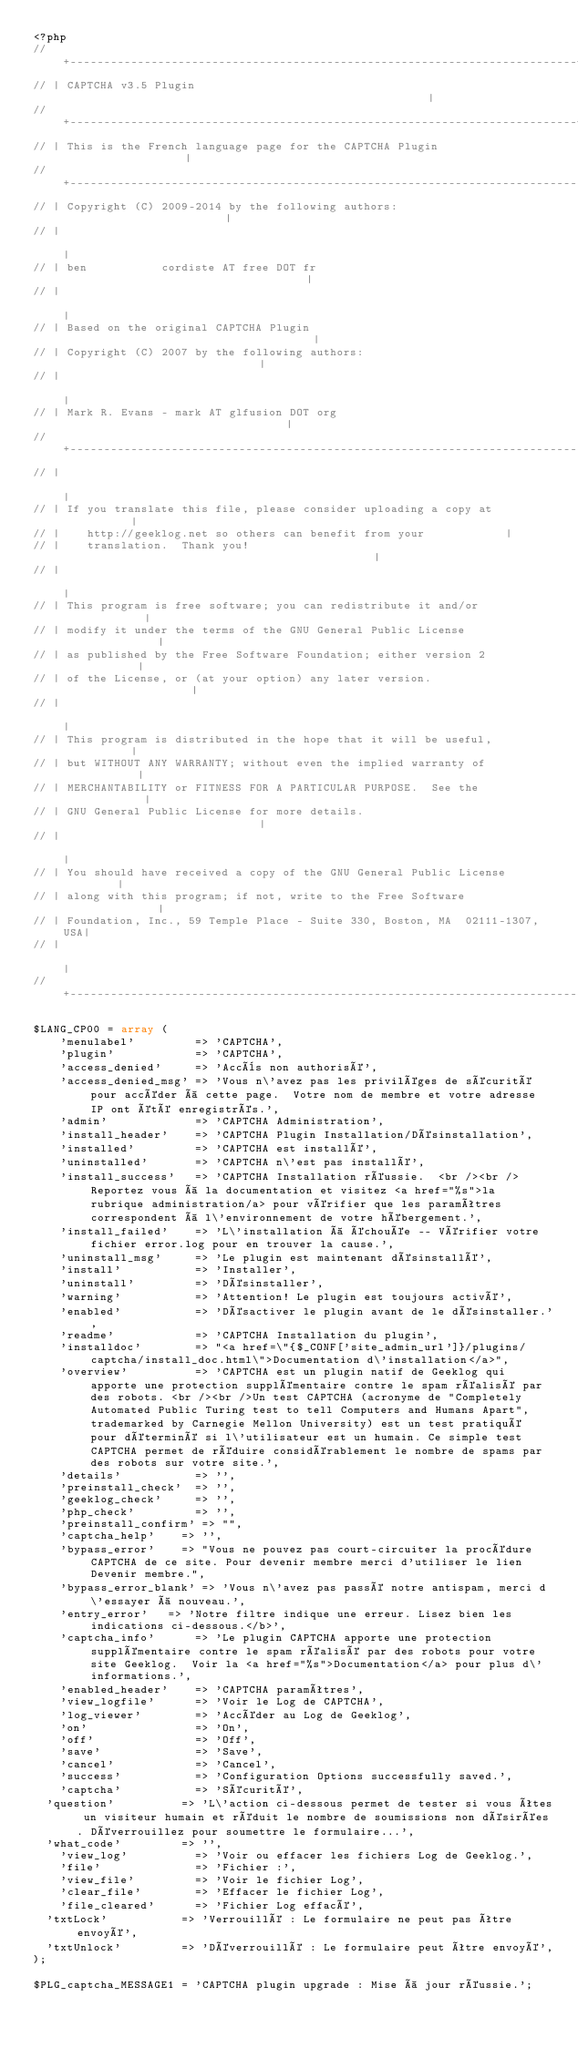Convert code to text. <code><loc_0><loc_0><loc_500><loc_500><_PHP_><?php
// +---------------------------------------------------------------------------+
// | CAPTCHA v3.5 Plugin                                                       |
// +---------------------------------------------------------------------------+
// | This is the French language page for the CAPTCHA Plugin                   |
// +---------------------------------------------------------------------------|
// | Copyright (C) 2009-2014 by the following authors:                         |
// |                                                                           |
// | ben           cordiste AT free DOT fr                                     |
// |                                                                           |
// | Based on the original CAPTCHA Plugin                                      |
// | Copyright (C) 2007 by the following authors:                              |
// |                                                                           |
// | Mark R. Evans - mark AT glfusion DOT org                                  | 
// +---------------------------------------------------------------------------|
// |                                                                           |
// | If you translate this file, please consider uploading a copy at           |
// |    http://geeklog.net so others can benefit from your            |
// |    translation.  Thank you!                                               |
// |                                                                           |
// | This program is free software; you can redistribute it and/or             |
// | modify it under the terms of the GNU General Public License               |
// | as published by the Free Software Foundation; either version 2            |
// | of the License, or (at your option) any later version.                    |
// |                                                                           |
// | This program is distributed in the hope that it will be useful,           |
// | but WITHOUT ANY WARRANTY; without even the implied warranty of            |
// | MERCHANTABILITY or FITNESS FOR A PARTICULAR PURPOSE.  See the             |
// | GNU General Public License for more details.                              |
// |                                                                           |
// | You should have received a copy of the GNU General Public License         |
// | along with this program; if not, write to the Free Software               |
// | Foundation, Inc., 59 Temple Place - Suite 330, Boston, MA  02111-1307, USA|
// |                                                                           |
// +---------------------------------------------------------------------------|

$LANG_CP00 = array (
    'menulabel'         => 'CAPTCHA',
    'plugin'            => 'CAPTCHA',
    'access_denied'     => 'Accès non authorisé',
    'access_denied_msg' => 'Vous n\'avez pas les priviléges de sécurité pour accéder à cette page.  Votre nom de membre et votre adresse IP ont été enregistrés.',
    'admin'             => 'CAPTCHA Administration',
    'install_header'    => 'CAPTCHA Plugin Installation/Désinstallation',
    'installed'         => 'CAPTCHA est installé',
    'uninstalled'       => 'CAPTCHA n\'est pas installé',
    'install_success'   => 'CAPTCHA Installation réussie.  <br /><br />Reportez vous à la documentation et visitez <a href="%s">la rubrique administration/a> pour vérifier que les paramêtres correspondent à l\'environnement de votre hébergement.',
    'install_failed'    => 'L\'installation à échouée -- Vérifier votre fichier error.log pour en trouver la cause.',
    'uninstall_msg'     => 'Le plugin est maintenant désinstallé',
    'install'           => 'Installer',
    'uninstall'         => 'Désinstaller',
    'warning'           => 'Attention! Le plugin est toujours activé',
    'enabled'           => 'Désactiver le plugin avant de le désinstaller.',
    'readme'            => 'CAPTCHA Installation du plugin',
    'installdoc'        => "<a href=\"{$_CONF['site_admin_url']}/plugins/captcha/install_doc.html\">Documentation d\'installation</a>",
    'overview'          => 'CAPTCHA est un plugin natif de Geeklog qui apporte une protection supplémentaire contre le spam réalisé par des robots. <br /><br />Un test CAPTCHA (acronyme de "Completely Automated Public Turing test to tell Computers and Humans Apart", trademarked by Carnegie Mellon University) est un test pratiqué pour déterminé si l\'utilisateur est un humain. Ce simple test CAPTCHA permet de réduire considérablement le nombre de spams par des robots sur votre site.',
    'details'           => '',
    'preinstall_check'  => '',
    'geeklog_check'     => '',
    'php_check'         => '',
    'preinstall_confirm' => "",
    'captcha_help'		=> '',
    'bypass_error'		=> "Vous ne pouvez pas court-circuiter la procédure CAPTCHA de ce site. Pour devenir membre merci d'utiliser le lien Devenir membre.",
    'bypass_error_blank' => 'Vous n\'avez pas passé notre antispam, merci d\'essayer à nouveau.',
    'entry_error'		=> 'Notre filtre indique une erreur. Lisez bien les indications ci-dessous.</b>',
    'captcha_info'      => 'Le plugin CAPTCHA apporte une protection supplémentaire contre le spam réalisé par des robots pour votre site Geeklog.  Voir la <a href="%s">Documentation</a> pour plus d\'informations.',
    'enabled_header'    => 'CAPTCHA paramêtres',
    'view_logfile'      => 'Voir le Log de CAPTCHA',
    'log_viewer'        => 'Accéder au Log de Geeklog',
    'on'                => 'On',
    'off'               => 'Off',
    'save'              => 'Save',
    'cancel'            => 'Cancel',
    'success'           => 'Configuration Options successfully saved.',
    'captcha'           => 'Sécurité',
	'question'          => 'L\'action ci-dessous permet de tester si vous êtes un visiteur humain et réduit le nombre de soumissions non désirées. Déverrouillez pour soumettre le formulaire...',
	'what_code'         => '',
    'view_log'          => 'Voir ou effacer les fichiers Log de Geeklog.',
    'file'              => 'Fichier :',
    'view_file'         => 'Voir le fichier Log',
    'clear_file'        => 'Effacer le fichier Log',
    'file_cleared'      => 'Fichier Log effacé',
	'txtLock'           => 'Verrouillé : Le formulaire ne peut pas être envoyé',
	'txtUnlock'         => 'Déverrouillé : Le formulaire peut être envoyé',
);

$PLG_captcha_MESSAGE1 = 'CAPTCHA plugin upgrade : Mise à jour réussie.';</code> 